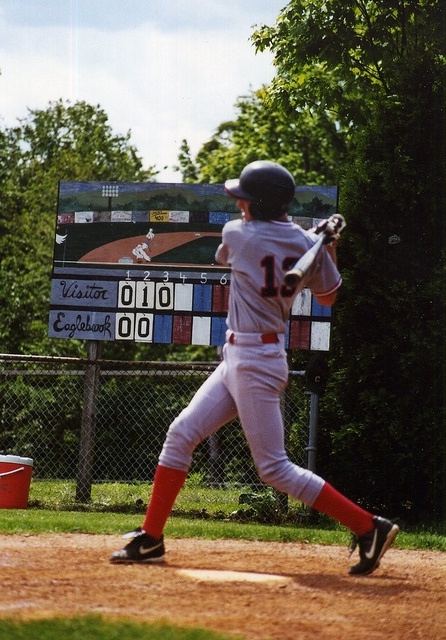Describe the objects in this image and their specific colors. I can see people in lightgray, purple, maroon, gray, and black tones, people in lightgray, black, gray, and darkgray tones, and baseball bat in lightgray, black, darkgray, and gray tones in this image. 